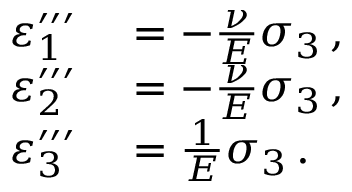<formula> <loc_0><loc_0><loc_500><loc_500>\begin{array} { r l } { \varepsilon _ { 1 } ^ { \prime \prime \prime } } & = - { \frac { \nu } { E } } \sigma _ { 3 } \, , } \\ { \varepsilon _ { 2 } ^ { \prime \prime \prime } } & = - { \frac { \nu } { E } } \sigma _ { 3 } \, , } \\ { \varepsilon _ { 3 } ^ { \prime \prime \prime } } & = { \frac { 1 } { E } } \sigma _ { 3 } \, . } \end{array}</formula> 